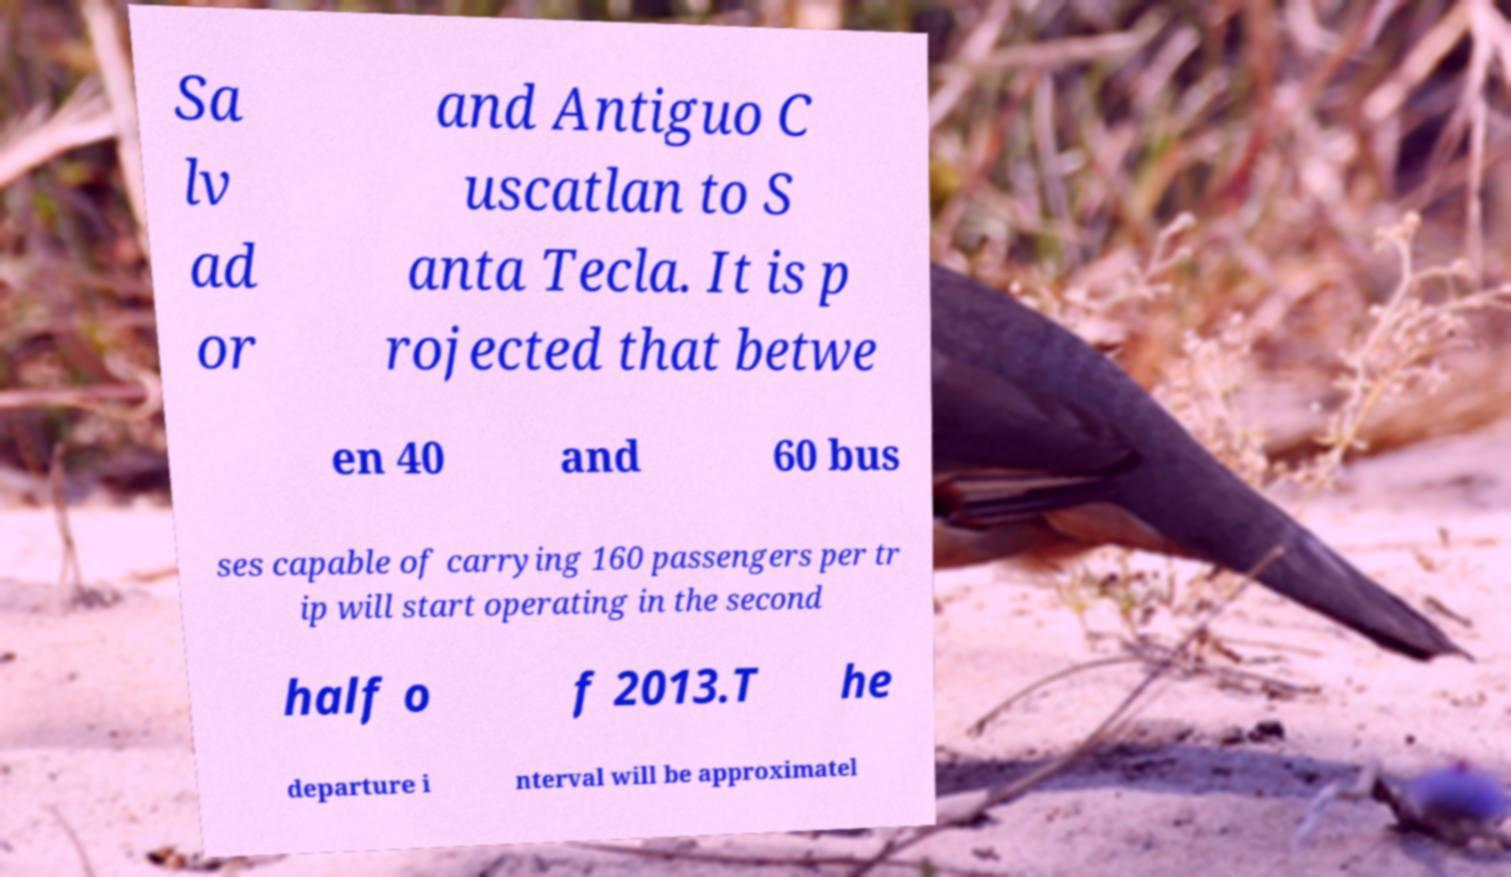What messages or text are displayed in this image? I need them in a readable, typed format. Sa lv ad or and Antiguo C uscatlan to S anta Tecla. It is p rojected that betwe en 40 and 60 bus ses capable of carrying 160 passengers per tr ip will start operating in the second half o f 2013.T he departure i nterval will be approximatel 